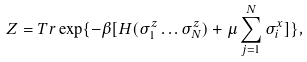Convert formula to latex. <formula><loc_0><loc_0><loc_500><loc_500>Z = T r \exp \{ - \beta [ H ( \sigma ^ { z } _ { 1 } \dots \sigma ^ { z } _ { N } ) + \mu \sum _ { j = 1 } ^ { N } \sigma ^ { x } _ { i } ] \} ,</formula> 